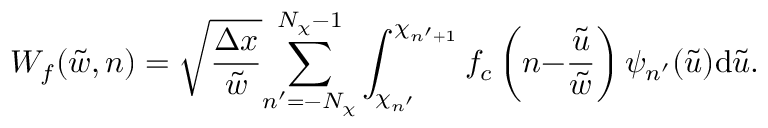<formula> <loc_0><loc_0><loc_500><loc_500>W _ { f } ( \tilde { w } , n ) = \sqrt { \frac { \Delta x } { \tilde { w } } } { \sum _ { n ^ { \prime } = - N _ { \chi } } ^ { N _ { \chi } - 1 } } \int _ { \chi _ { n ^ { \prime } } } ^ { \chi _ { n ^ { \prime } { + } 1 } } f _ { c } \left ( n { - } \frac { \tilde { u } } { \tilde { w } } \right ) \psi _ { n ^ { \prime } } ( \tilde { u } ) d \tilde { u } .</formula> 